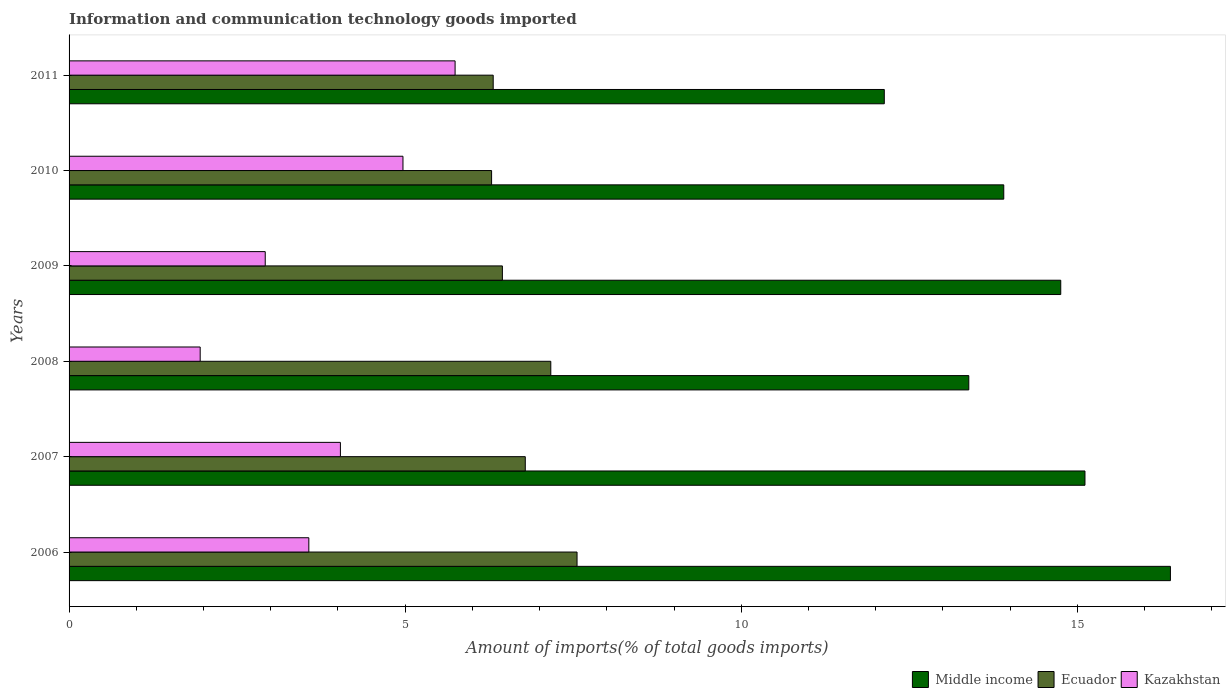How many different coloured bars are there?
Offer a very short reply. 3. How many groups of bars are there?
Ensure brevity in your answer.  6. Are the number of bars per tick equal to the number of legend labels?
Your answer should be very brief. Yes. How many bars are there on the 2nd tick from the top?
Offer a terse response. 3. How many bars are there on the 6th tick from the bottom?
Your response must be concise. 3. What is the label of the 4th group of bars from the top?
Provide a succinct answer. 2008. What is the amount of goods imported in Kazakhstan in 2007?
Make the answer very short. 4.04. Across all years, what is the maximum amount of goods imported in Ecuador?
Keep it short and to the point. 7.56. Across all years, what is the minimum amount of goods imported in Middle income?
Give a very brief answer. 12.13. In which year was the amount of goods imported in Middle income maximum?
Your answer should be very brief. 2006. In which year was the amount of goods imported in Middle income minimum?
Give a very brief answer. 2011. What is the total amount of goods imported in Kazakhstan in the graph?
Ensure brevity in your answer.  23.18. What is the difference between the amount of goods imported in Middle income in 2006 and that in 2008?
Make the answer very short. 3. What is the difference between the amount of goods imported in Kazakhstan in 2006 and the amount of goods imported in Middle income in 2009?
Offer a terse response. -11.19. What is the average amount of goods imported in Kazakhstan per year?
Provide a succinct answer. 3.86. In the year 2010, what is the difference between the amount of goods imported in Kazakhstan and amount of goods imported in Ecuador?
Provide a succinct answer. -1.32. In how many years, is the amount of goods imported in Middle income greater than 10 %?
Offer a very short reply. 6. What is the ratio of the amount of goods imported in Ecuador in 2007 to that in 2010?
Keep it short and to the point. 1.08. Is the difference between the amount of goods imported in Kazakhstan in 2006 and 2011 greater than the difference between the amount of goods imported in Ecuador in 2006 and 2011?
Give a very brief answer. No. What is the difference between the highest and the second highest amount of goods imported in Middle income?
Give a very brief answer. 1.27. What is the difference between the highest and the lowest amount of goods imported in Middle income?
Provide a short and direct response. 4.26. Is the sum of the amount of goods imported in Kazakhstan in 2008 and 2009 greater than the maximum amount of goods imported in Middle income across all years?
Give a very brief answer. No. What does the 2nd bar from the top in 2006 represents?
Your response must be concise. Ecuador. What does the 2nd bar from the bottom in 2007 represents?
Keep it short and to the point. Ecuador. Is it the case that in every year, the sum of the amount of goods imported in Kazakhstan and amount of goods imported in Ecuador is greater than the amount of goods imported in Middle income?
Ensure brevity in your answer.  No. What is the difference between two consecutive major ticks on the X-axis?
Your response must be concise. 5. Are the values on the major ticks of X-axis written in scientific E-notation?
Offer a terse response. No. Does the graph contain any zero values?
Provide a succinct answer. No. Where does the legend appear in the graph?
Keep it short and to the point. Bottom right. What is the title of the graph?
Your answer should be compact. Information and communication technology goods imported. Does "Morocco" appear as one of the legend labels in the graph?
Ensure brevity in your answer.  No. What is the label or title of the X-axis?
Provide a short and direct response. Amount of imports(% of total goods imports). What is the label or title of the Y-axis?
Your response must be concise. Years. What is the Amount of imports(% of total goods imports) of Middle income in 2006?
Your answer should be very brief. 16.38. What is the Amount of imports(% of total goods imports) in Ecuador in 2006?
Provide a succinct answer. 7.56. What is the Amount of imports(% of total goods imports) in Kazakhstan in 2006?
Provide a short and direct response. 3.57. What is the Amount of imports(% of total goods imports) in Middle income in 2007?
Make the answer very short. 15.11. What is the Amount of imports(% of total goods imports) of Ecuador in 2007?
Give a very brief answer. 6.79. What is the Amount of imports(% of total goods imports) in Kazakhstan in 2007?
Your response must be concise. 4.04. What is the Amount of imports(% of total goods imports) in Middle income in 2008?
Your answer should be compact. 13.38. What is the Amount of imports(% of total goods imports) of Ecuador in 2008?
Keep it short and to the point. 7.17. What is the Amount of imports(% of total goods imports) in Kazakhstan in 2008?
Offer a very short reply. 1.95. What is the Amount of imports(% of total goods imports) of Middle income in 2009?
Your answer should be very brief. 14.75. What is the Amount of imports(% of total goods imports) in Ecuador in 2009?
Keep it short and to the point. 6.45. What is the Amount of imports(% of total goods imports) of Kazakhstan in 2009?
Provide a short and direct response. 2.92. What is the Amount of imports(% of total goods imports) of Middle income in 2010?
Offer a very short reply. 13.9. What is the Amount of imports(% of total goods imports) in Ecuador in 2010?
Your response must be concise. 6.29. What is the Amount of imports(% of total goods imports) of Kazakhstan in 2010?
Your response must be concise. 4.97. What is the Amount of imports(% of total goods imports) of Middle income in 2011?
Provide a succinct answer. 12.13. What is the Amount of imports(% of total goods imports) in Ecuador in 2011?
Your answer should be very brief. 6.31. What is the Amount of imports(% of total goods imports) of Kazakhstan in 2011?
Ensure brevity in your answer.  5.74. Across all years, what is the maximum Amount of imports(% of total goods imports) of Middle income?
Provide a succinct answer. 16.38. Across all years, what is the maximum Amount of imports(% of total goods imports) in Ecuador?
Offer a terse response. 7.56. Across all years, what is the maximum Amount of imports(% of total goods imports) in Kazakhstan?
Your answer should be very brief. 5.74. Across all years, what is the minimum Amount of imports(% of total goods imports) in Middle income?
Your response must be concise. 12.13. Across all years, what is the minimum Amount of imports(% of total goods imports) in Ecuador?
Keep it short and to the point. 6.29. Across all years, what is the minimum Amount of imports(% of total goods imports) in Kazakhstan?
Your answer should be very brief. 1.95. What is the total Amount of imports(% of total goods imports) in Middle income in the graph?
Your answer should be compact. 85.67. What is the total Amount of imports(% of total goods imports) of Ecuador in the graph?
Your response must be concise. 40.55. What is the total Amount of imports(% of total goods imports) of Kazakhstan in the graph?
Provide a succinct answer. 23.18. What is the difference between the Amount of imports(% of total goods imports) of Middle income in 2006 and that in 2007?
Offer a very short reply. 1.27. What is the difference between the Amount of imports(% of total goods imports) in Ecuador in 2006 and that in 2007?
Offer a terse response. 0.77. What is the difference between the Amount of imports(% of total goods imports) of Kazakhstan in 2006 and that in 2007?
Offer a terse response. -0.47. What is the difference between the Amount of imports(% of total goods imports) in Middle income in 2006 and that in 2008?
Your answer should be compact. 3. What is the difference between the Amount of imports(% of total goods imports) in Ecuador in 2006 and that in 2008?
Provide a short and direct response. 0.39. What is the difference between the Amount of imports(% of total goods imports) in Kazakhstan in 2006 and that in 2008?
Make the answer very short. 1.62. What is the difference between the Amount of imports(% of total goods imports) of Middle income in 2006 and that in 2009?
Your response must be concise. 1.63. What is the difference between the Amount of imports(% of total goods imports) of Ecuador in 2006 and that in 2009?
Your answer should be compact. 1.11. What is the difference between the Amount of imports(% of total goods imports) of Kazakhstan in 2006 and that in 2009?
Give a very brief answer. 0.65. What is the difference between the Amount of imports(% of total goods imports) in Middle income in 2006 and that in 2010?
Give a very brief answer. 2.48. What is the difference between the Amount of imports(% of total goods imports) in Ecuador in 2006 and that in 2010?
Give a very brief answer. 1.27. What is the difference between the Amount of imports(% of total goods imports) in Kazakhstan in 2006 and that in 2010?
Keep it short and to the point. -1.4. What is the difference between the Amount of imports(% of total goods imports) of Middle income in 2006 and that in 2011?
Offer a terse response. 4.26. What is the difference between the Amount of imports(% of total goods imports) in Ecuador in 2006 and that in 2011?
Offer a terse response. 1.25. What is the difference between the Amount of imports(% of total goods imports) in Kazakhstan in 2006 and that in 2011?
Give a very brief answer. -2.18. What is the difference between the Amount of imports(% of total goods imports) in Middle income in 2007 and that in 2008?
Make the answer very short. 1.73. What is the difference between the Amount of imports(% of total goods imports) of Ecuador in 2007 and that in 2008?
Keep it short and to the point. -0.38. What is the difference between the Amount of imports(% of total goods imports) in Kazakhstan in 2007 and that in 2008?
Provide a succinct answer. 2.09. What is the difference between the Amount of imports(% of total goods imports) of Middle income in 2007 and that in 2009?
Keep it short and to the point. 0.36. What is the difference between the Amount of imports(% of total goods imports) of Ecuador in 2007 and that in 2009?
Provide a short and direct response. 0.34. What is the difference between the Amount of imports(% of total goods imports) in Kazakhstan in 2007 and that in 2009?
Your answer should be compact. 1.12. What is the difference between the Amount of imports(% of total goods imports) in Middle income in 2007 and that in 2010?
Offer a very short reply. 1.21. What is the difference between the Amount of imports(% of total goods imports) of Ecuador in 2007 and that in 2010?
Your response must be concise. 0.5. What is the difference between the Amount of imports(% of total goods imports) in Kazakhstan in 2007 and that in 2010?
Your answer should be very brief. -0.93. What is the difference between the Amount of imports(% of total goods imports) of Middle income in 2007 and that in 2011?
Give a very brief answer. 2.99. What is the difference between the Amount of imports(% of total goods imports) in Ecuador in 2007 and that in 2011?
Ensure brevity in your answer.  0.48. What is the difference between the Amount of imports(% of total goods imports) of Kazakhstan in 2007 and that in 2011?
Your answer should be very brief. -1.71. What is the difference between the Amount of imports(% of total goods imports) in Middle income in 2008 and that in 2009?
Ensure brevity in your answer.  -1.37. What is the difference between the Amount of imports(% of total goods imports) of Ecuador in 2008 and that in 2009?
Make the answer very short. 0.72. What is the difference between the Amount of imports(% of total goods imports) in Kazakhstan in 2008 and that in 2009?
Ensure brevity in your answer.  -0.97. What is the difference between the Amount of imports(% of total goods imports) in Middle income in 2008 and that in 2010?
Your response must be concise. -0.52. What is the difference between the Amount of imports(% of total goods imports) in Ecuador in 2008 and that in 2010?
Offer a very short reply. 0.88. What is the difference between the Amount of imports(% of total goods imports) in Kazakhstan in 2008 and that in 2010?
Make the answer very short. -3.02. What is the difference between the Amount of imports(% of total goods imports) in Middle income in 2008 and that in 2011?
Make the answer very short. 1.26. What is the difference between the Amount of imports(% of total goods imports) in Ecuador in 2008 and that in 2011?
Offer a terse response. 0.86. What is the difference between the Amount of imports(% of total goods imports) of Kazakhstan in 2008 and that in 2011?
Ensure brevity in your answer.  -3.79. What is the difference between the Amount of imports(% of total goods imports) in Middle income in 2009 and that in 2010?
Make the answer very short. 0.85. What is the difference between the Amount of imports(% of total goods imports) of Ecuador in 2009 and that in 2010?
Keep it short and to the point. 0.16. What is the difference between the Amount of imports(% of total goods imports) of Kazakhstan in 2009 and that in 2010?
Give a very brief answer. -2.05. What is the difference between the Amount of imports(% of total goods imports) of Middle income in 2009 and that in 2011?
Your answer should be compact. 2.62. What is the difference between the Amount of imports(% of total goods imports) of Ecuador in 2009 and that in 2011?
Give a very brief answer. 0.14. What is the difference between the Amount of imports(% of total goods imports) in Kazakhstan in 2009 and that in 2011?
Give a very brief answer. -2.82. What is the difference between the Amount of imports(% of total goods imports) of Middle income in 2010 and that in 2011?
Ensure brevity in your answer.  1.78. What is the difference between the Amount of imports(% of total goods imports) of Ecuador in 2010 and that in 2011?
Offer a very short reply. -0.02. What is the difference between the Amount of imports(% of total goods imports) of Kazakhstan in 2010 and that in 2011?
Make the answer very short. -0.78. What is the difference between the Amount of imports(% of total goods imports) in Middle income in 2006 and the Amount of imports(% of total goods imports) in Ecuador in 2007?
Offer a very short reply. 9.6. What is the difference between the Amount of imports(% of total goods imports) of Middle income in 2006 and the Amount of imports(% of total goods imports) of Kazakhstan in 2007?
Offer a very short reply. 12.35. What is the difference between the Amount of imports(% of total goods imports) in Ecuador in 2006 and the Amount of imports(% of total goods imports) in Kazakhstan in 2007?
Offer a very short reply. 3.52. What is the difference between the Amount of imports(% of total goods imports) of Middle income in 2006 and the Amount of imports(% of total goods imports) of Ecuador in 2008?
Offer a terse response. 9.22. What is the difference between the Amount of imports(% of total goods imports) in Middle income in 2006 and the Amount of imports(% of total goods imports) in Kazakhstan in 2008?
Your answer should be compact. 14.43. What is the difference between the Amount of imports(% of total goods imports) of Ecuador in 2006 and the Amount of imports(% of total goods imports) of Kazakhstan in 2008?
Your answer should be compact. 5.61. What is the difference between the Amount of imports(% of total goods imports) in Middle income in 2006 and the Amount of imports(% of total goods imports) in Ecuador in 2009?
Provide a succinct answer. 9.94. What is the difference between the Amount of imports(% of total goods imports) in Middle income in 2006 and the Amount of imports(% of total goods imports) in Kazakhstan in 2009?
Give a very brief answer. 13.47. What is the difference between the Amount of imports(% of total goods imports) in Ecuador in 2006 and the Amount of imports(% of total goods imports) in Kazakhstan in 2009?
Your response must be concise. 4.64. What is the difference between the Amount of imports(% of total goods imports) of Middle income in 2006 and the Amount of imports(% of total goods imports) of Ecuador in 2010?
Offer a terse response. 10.1. What is the difference between the Amount of imports(% of total goods imports) in Middle income in 2006 and the Amount of imports(% of total goods imports) in Kazakhstan in 2010?
Your response must be concise. 11.42. What is the difference between the Amount of imports(% of total goods imports) of Ecuador in 2006 and the Amount of imports(% of total goods imports) of Kazakhstan in 2010?
Provide a succinct answer. 2.59. What is the difference between the Amount of imports(% of total goods imports) of Middle income in 2006 and the Amount of imports(% of total goods imports) of Ecuador in 2011?
Offer a terse response. 10.07. What is the difference between the Amount of imports(% of total goods imports) in Middle income in 2006 and the Amount of imports(% of total goods imports) in Kazakhstan in 2011?
Give a very brief answer. 10.64. What is the difference between the Amount of imports(% of total goods imports) in Ecuador in 2006 and the Amount of imports(% of total goods imports) in Kazakhstan in 2011?
Offer a terse response. 1.81. What is the difference between the Amount of imports(% of total goods imports) of Middle income in 2007 and the Amount of imports(% of total goods imports) of Ecuador in 2008?
Offer a very short reply. 7.95. What is the difference between the Amount of imports(% of total goods imports) in Middle income in 2007 and the Amount of imports(% of total goods imports) in Kazakhstan in 2008?
Provide a succinct answer. 13.16. What is the difference between the Amount of imports(% of total goods imports) in Ecuador in 2007 and the Amount of imports(% of total goods imports) in Kazakhstan in 2008?
Ensure brevity in your answer.  4.84. What is the difference between the Amount of imports(% of total goods imports) of Middle income in 2007 and the Amount of imports(% of total goods imports) of Ecuador in 2009?
Keep it short and to the point. 8.67. What is the difference between the Amount of imports(% of total goods imports) of Middle income in 2007 and the Amount of imports(% of total goods imports) of Kazakhstan in 2009?
Your response must be concise. 12.19. What is the difference between the Amount of imports(% of total goods imports) in Ecuador in 2007 and the Amount of imports(% of total goods imports) in Kazakhstan in 2009?
Keep it short and to the point. 3.87. What is the difference between the Amount of imports(% of total goods imports) in Middle income in 2007 and the Amount of imports(% of total goods imports) in Ecuador in 2010?
Give a very brief answer. 8.83. What is the difference between the Amount of imports(% of total goods imports) in Middle income in 2007 and the Amount of imports(% of total goods imports) in Kazakhstan in 2010?
Your answer should be very brief. 10.15. What is the difference between the Amount of imports(% of total goods imports) in Ecuador in 2007 and the Amount of imports(% of total goods imports) in Kazakhstan in 2010?
Your response must be concise. 1.82. What is the difference between the Amount of imports(% of total goods imports) of Middle income in 2007 and the Amount of imports(% of total goods imports) of Ecuador in 2011?
Provide a succinct answer. 8.8. What is the difference between the Amount of imports(% of total goods imports) of Middle income in 2007 and the Amount of imports(% of total goods imports) of Kazakhstan in 2011?
Your answer should be compact. 9.37. What is the difference between the Amount of imports(% of total goods imports) of Ecuador in 2007 and the Amount of imports(% of total goods imports) of Kazakhstan in 2011?
Keep it short and to the point. 1.04. What is the difference between the Amount of imports(% of total goods imports) of Middle income in 2008 and the Amount of imports(% of total goods imports) of Ecuador in 2009?
Give a very brief answer. 6.94. What is the difference between the Amount of imports(% of total goods imports) of Middle income in 2008 and the Amount of imports(% of total goods imports) of Kazakhstan in 2009?
Give a very brief answer. 10.47. What is the difference between the Amount of imports(% of total goods imports) of Ecuador in 2008 and the Amount of imports(% of total goods imports) of Kazakhstan in 2009?
Keep it short and to the point. 4.25. What is the difference between the Amount of imports(% of total goods imports) of Middle income in 2008 and the Amount of imports(% of total goods imports) of Ecuador in 2010?
Your answer should be very brief. 7.1. What is the difference between the Amount of imports(% of total goods imports) of Middle income in 2008 and the Amount of imports(% of total goods imports) of Kazakhstan in 2010?
Give a very brief answer. 8.42. What is the difference between the Amount of imports(% of total goods imports) in Ecuador in 2008 and the Amount of imports(% of total goods imports) in Kazakhstan in 2010?
Your response must be concise. 2.2. What is the difference between the Amount of imports(% of total goods imports) in Middle income in 2008 and the Amount of imports(% of total goods imports) in Ecuador in 2011?
Provide a succinct answer. 7.08. What is the difference between the Amount of imports(% of total goods imports) in Middle income in 2008 and the Amount of imports(% of total goods imports) in Kazakhstan in 2011?
Ensure brevity in your answer.  7.64. What is the difference between the Amount of imports(% of total goods imports) of Ecuador in 2008 and the Amount of imports(% of total goods imports) of Kazakhstan in 2011?
Provide a short and direct response. 1.42. What is the difference between the Amount of imports(% of total goods imports) in Middle income in 2009 and the Amount of imports(% of total goods imports) in Ecuador in 2010?
Your response must be concise. 8.47. What is the difference between the Amount of imports(% of total goods imports) in Middle income in 2009 and the Amount of imports(% of total goods imports) in Kazakhstan in 2010?
Keep it short and to the point. 9.79. What is the difference between the Amount of imports(% of total goods imports) in Ecuador in 2009 and the Amount of imports(% of total goods imports) in Kazakhstan in 2010?
Your answer should be very brief. 1.48. What is the difference between the Amount of imports(% of total goods imports) in Middle income in 2009 and the Amount of imports(% of total goods imports) in Ecuador in 2011?
Your answer should be compact. 8.44. What is the difference between the Amount of imports(% of total goods imports) of Middle income in 2009 and the Amount of imports(% of total goods imports) of Kazakhstan in 2011?
Keep it short and to the point. 9.01. What is the difference between the Amount of imports(% of total goods imports) of Ecuador in 2009 and the Amount of imports(% of total goods imports) of Kazakhstan in 2011?
Offer a very short reply. 0.7. What is the difference between the Amount of imports(% of total goods imports) of Middle income in 2010 and the Amount of imports(% of total goods imports) of Ecuador in 2011?
Provide a short and direct response. 7.6. What is the difference between the Amount of imports(% of total goods imports) in Middle income in 2010 and the Amount of imports(% of total goods imports) in Kazakhstan in 2011?
Your answer should be compact. 8.16. What is the difference between the Amount of imports(% of total goods imports) in Ecuador in 2010 and the Amount of imports(% of total goods imports) in Kazakhstan in 2011?
Give a very brief answer. 0.54. What is the average Amount of imports(% of total goods imports) of Middle income per year?
Provide a short and direct response. 14.28. What is the average Amount of imports(% of total goods imports) of Ecuador per year?
Offer a very short reply. 6.76. What is the average Amount of imports(% of total goods imports) of Kazakhstan per year?
Give a very brief answer. 3.86. In the year 2006, what is the difference between the Amount of imports(% of total goods imports) in Middle income and Amount of imports(% of total goods imports) in Ecuador?
Provide a short and direct response. 8.83. In the year 2006, what is the difference between the Amount of imports(% of total goods imports) in Middle income and Amount of imports(% of total goods imports) in Kazakhstan?
Provide a succinct answer. 12.82. In the year 2006, what is the difference between the Amount of imports(% of total goods imports) of Ecuador and Amount of imports(% of total goods imports) of Kazakhstan?
Offer a terse response. 3.99. In the year 2007, what is the difference between the Amount of imports(% of total goods imports) of Middle income and Amount of imports(% of total goods imports) of Ecuador?
Provide a short and direct response. 8.33. In the year 2007, what is the difference between the Amount of imports(% of total goods imports) of Middle income and Amount of imports(% of total goods imports) of Kazakhstan?
Offer a very short reply. 11.08. In the year 2007, what is the difference between the Amount of imports(% of total goods imports) of Ecuador and Amount of imports(% of total goods imports) of Kazakhstan?
Your answer should be very brief. 2.75. In the year 2008, what is the difference between the Amount of imports(% of total goods imports) in Middle income and Amount of imports(% of total goods imports) in Ecuador?
Offer a terse response. 6.22. In the year 2008, what is the difference between the Amount of imports(% of total goods imports) in Middle income and Amount of imports(% of total goods imports) in Kazakhstan?
Make the answer very short. 11.43. In the year 2008, what is the difference between the Amount of imports(% of total goods imports) of Ecuador and Amount of imports(% of total goods imports) of Kazakhstan?
Make the answer very short. 5.22. In the year 2009, what is the difference between the Amount of imports(% of total goods imports) in Middle income and Amount of imports(% of total goods imports) in Ecuador?
Your response must be concise. 8.31. In the year 2009, what is the difference between the Amount of imports(% of total goods imports) in Middle income and Amount of imports(% of total goods imports) in Kazakhstan?
Your response must be concise. 11.83. In the year 2009, what is the difference between the Amount of imports(% of total goods imports) in Ecuador and Amount of imports(% of total goods imports) in Kazakhstan?
Your answer should be very brief. 3.53. In the year 2010, what is the difference between the Amount of imports(% of total goods imports) of Middle income and Amount of imports(% of total goods imports) of Ecuador?
Provide a succinct answer. 7.62. In the year 2010, what is the difference between the Amount of imports(% of total goods imports) of Middle income and Amount of imports(% of total goods imports) of Kazakhstan?
Your answer should be very brief. 8.94. In the year 2010, what is the difference between the Amount of imports(% of total goods imports) of Ecuador and Amount of imports(% of total goods imports) of Kazakhstan?
Offer a terse response. 1.32. In the year 2011, what is the difference between the Amount of imports(% of total goods imports) of Middle income and Amount of imports(% of total goods imports) of Ecuador?
Your answer should be compact. 5.82. In the year 2011, what is the difference between the Amount of imports(% of total goods imports) in Middle income and Amount of imports(% of total goods imports) in Kazakhstan?
Your answer should be compact. 6.38. In the year 2011, what is the difference between the Amount of imports(% of total goods imports) in Ecuador and Amount of imports(% of total goods imports) in Kazakhstan?
Offer a very short reply. 0.57. What is the ratio of the Amount of imports(% of total goods imports) of Middle income in 2006 to that in 2007?
Your response must be concise. 1.08. What is the ratio of the Amount of imports(% of total goods imports) in Ecuador in 2006 to that in 2007?
Your response must be concise. 1.11. What is the ratio of the Amount of imports(% of total goods imports) of Kazakhstan in 2006 to that in 2007?
Your answer should be very brief. 0.88. What is the ratio of the Amount of imports(% of total goods imports) of Middle income in 2006 to that in 2008?
Make the answer very short. 1.22. What is the ratio of the Amount of imports(% of total goods imports) in Ecuador in 2006 to that in 2008?
Offer a terse response. 1.05. What is the ratio of the Amount of imports(% of total goods imports) in Kazakhstan in 2006 to that in 2008?
Provide a succinct answer. 1.83. What is the ratio of the Amount of imports(% of total goods imports) in Middle income in 2006 to that in 2009?
Make the answer very short. 1.11. What is the ratio of the Amount of imports(% of total goods imports) of Ecuador in 2006 to that in 2009?
Offer a very short reply. 1.17. What is the ratio of the Amount of imports(% of total goods imports) of Kazakhstan in 2006 to that in 2009?
Make the answer very short. 1.22. What is the ratio of the Amount of imports(% of total goods imports) of Middle income in 2006 to that in 2010?
Your answer should be compact. 1.18. What is the ratio of the Amount of imports(% of total goods imports) of Ecuador in 2006 to that in 2010?
Offer a very short reply. 1.2. What is the ratio of the Amount of imports(% of total goods imports) of Kazakhstan in 2006 to that in 2010?
Give a very brief answer. 0.72. What is the ratio of the Amount of imports(% of total goods imports) of Middle income in 2006 to that in 2011?
Keep it short and to the point. 1.35. What is the ratio of the Amount of imports(% of total goods imports) in Ecuador in 2006 to that in 2011?
Provide a succinct answer. 1.2. What is the ratio of the Amount of imports(% of total goods imports) in Kazakhstan in 2006 to that in 2011?
Offer a terse response. 0.62. What is the ratio of the Amount of imports(% of total goods imports) in Middle income in 2007 to that in 2008?
Provide a short and direct response. 1.13. What is the ratio of the Amount of imports(% of total goods imports) of Ecuador in 2007 to that in 2008?
Your answer should be compact. 0.95. What is the ratio of the Amount of imports(% of total goods imports) of Kazakhstan in 2007 to that in 2008?
Offer a very short reply. 2.07. What is the ratio of the Amount of imports(% of total goods imports) of Middle income in 2007 to that in 2009?
Provide a succinct answer. 1.02. What is the ratio of the Amount of imports(% of total goods imports) in Ecuador in 2007 to that in 2009?
Your answer should be compact. 1.05. What is the ratio of the Amount of imports(% of total goods imports) of Kazakhstan in 2007 to that in 2009?
Ensure brevity in your answer.  1.38. What is the ratio of the Amount of imports(% of total goods imports) of Middle income in 2007 to that in 2010?
Your answer should be compact. 1.09. What is the ratio of the Amount of imports(% of total goods imports) of Ecuador in 2007 to that in 2010?
Provide a short and direct response. 1.08. What is the ratio of the Amount of imports(% of total goods imports) of Kazakhstan in 2007 to that in 2010?
Offer a very short reply. 0.81. What is the ratio of the Amount of imports(% of total goods imports) in Middle income in 2007 to that in 2011?
Provide a short and direct response. 1.25. What is the ratio of the Amount of imports(% of total goods imports) of Ecuador in 2007 to that in 2011?
Make the answer very short. 1.08. What is the ratio of the Amount of imports(% of total goods imports) in Kazakhstan in 2007 to that in 2011?
Give a very brief answer. 0.7. What is the ratio of the Amount of imports(% of total goods imports) of Middle income in 2008 to that in 2009?
Ensure brevity in your answer.  0.91. What is the ratio of the Amount of imports(% of total goods imports) of Ecuador in 2008 to that in 2009?
Provide a succinct answer. 1.11. What is the ratio of the Amount of imports(% of total goods imports) of Kazakhstan in 2008 to that in 2009?
Provide a short and direct response. 0.67. What is the ratio of the Amount of imports(% of total goods imports) in Middle income in 2008 to that in 2010?
Your answer should be very brief. 0.96. What is the ratio of the Amount of imports(% of total goods imports) in Ecuador in 2008 to that in 2010?
Your response must be concise. 1.14. What is the ratio of the Amount of imports(% of total goods imports) in Kazakhstan in 2008 to that in 2010?
Ensure brevity in your answer.  0.39. What is the ratio of the Amount of imports(% of total goods imports) of Middle income in 2008 to that in 2011?
Your answer should be very brief. 1.1. What is the ratio of the Amount of imports(% of total goods imports) in Ecuador in 2008 to that in 2011?
Provide a short and direct response. 1.14. What is the ratio of the Amount of imports(% of total goods imports) of Kazakhstan in 2008 to that in 2011?
Make the answer very short. 0.34. What is the ratio of the Amount of imports(% of total goods imports) of Middle income in 2009 to that in 2010?
Provide a succinct answer. 1.06. What is the ratio of the Amount of imports(% of total goods imports) in Ecuador in 2009 to that in 2010?
Provide a short and direct response. 1.03. What is the ratio of the Amount of imports(% of total goods imports) of Kazakhstan in 2009 to that in 2010?
Offer a terse response. 0.59. What is the ratio of the Amount of imports(% of total goods imports) of Middle income in 2009 to that in 2011?
Keep it short and to the point. 1.22. What is the ratio of the Amount of imports(% of total goods imports) of Ecuador in 2009 to that in 2011?
Provide a short and direct response. 1.02. What is the ratio of the Amount of imports(% of total goods imports) of Kazakhstan in 2009 to that in 2011?
Keep it short and to the point. 0.51. What is the ratio of the Amount of imports(% of total goods imports) in Middle income in 2010 to that in 2011?
Your answer should be compact. 1.15. What is the ratio of the Amount of imports(% of total goods imports) in Ecuador in 2010 to that in 2011?
Keep it short and to the point. 1. What is the ratio of the Amount of imports(% of total goods imports) in Kazakhstan in 2010 to that in 2011?
Offer a terse response. 0.86. What is the difference between the highest and the second highest Amount of imports(% of total goods imports) in Middle income?
Give a very brief answer. 1.27. What is the difference between the highest and the second highest Amount of imports(% of total goods imports) in Ecuador?
Your response must be concise. 0.39. What is the difference between the highest and the second highest Amount of imports(% of total goods imports) of Kazakhstan?
Provide a short and direct response. 0.78. What is the difference between the highest and the lowest Amount of imports(% of total goods imports) of Middle income?
Provide a succinct answer. 4.26. What is the difference between the highest and the lowest Amount of imports(% of total goods imports) in Ecuador?
Offer a terse response. 1.27. What is the difference between the highest and the lowest Amount of imports(% of total goods imports) in Kazakhstan?
Keep it short and to the point. 3.79. 